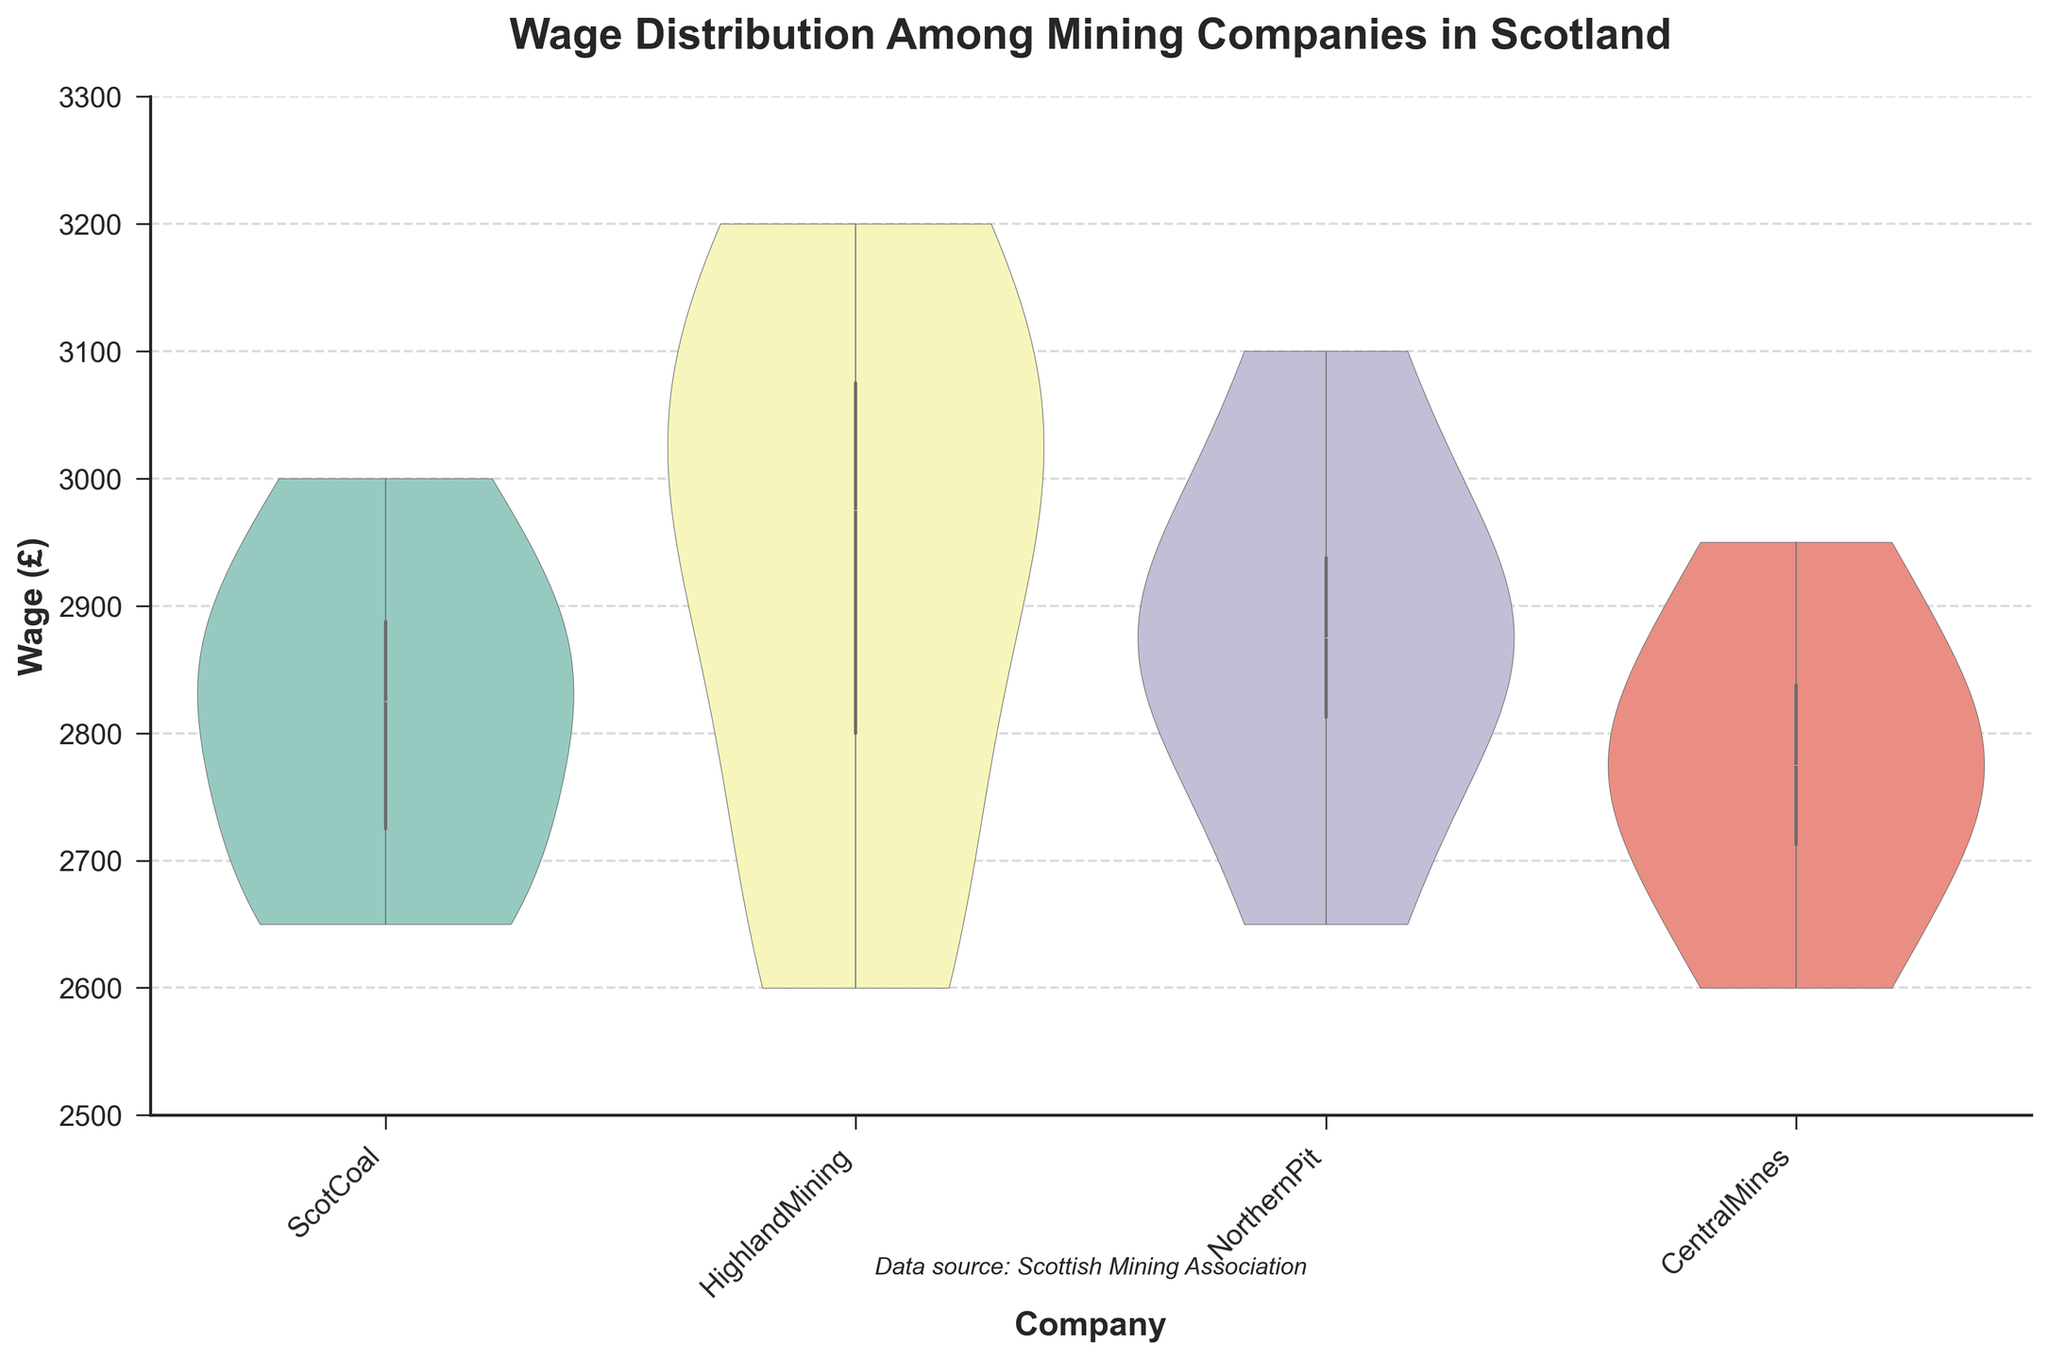What's the title of the figure? The title of the figure is usually the most prominent text and is located at the top of the chart.
Answer: Wage Distribution Among Mining Companies in Scotland What is the range of wages shown on the y-axis? The y-axis is labeled with "Wage (£)" and shows a range from 2500 to 3300 based on the ticks and labels.
Answer: 2500 to 3300 Which company has the highest median wage? The highest median wage can be found by locating the middle line within each violin plot and comparing their vertical positions.
Answer: HighlandMining Among the companies, which one has the most variability in wage distribution? The company with the broadest span in the violin plot indicates the most variability. This can be seen from the width and spread of the violin shape.
Answer: HighlandMining Is the wage for ScotCoal generally higher or lower than CentralMines? Compare the heights and positions of the distribution in the violin plots for ScotCoal and CentralMines. ScotCoal’s median appears slightly higher.
Answer: Higher What is the lower limit of the interquartile range (IQR) for NorthernPit? The interquartile range can be found within the thicker part of the violin plot. For NorthernPit, the lower limit of the IQR appears around 2800.
Answer: 2800 Which company shows the smallest median wage? By finding the middle line inside each violin plot and comparing their heights, the company with the smallest median wage becomes apparent.
Answer: CentralMines Are there any companies with non-overlapping wage distributions? Look for violin plots that do not intersect vertically. These distributions are entirely separate from one another.
Answer: No What visual elements indicate the presence of any outliers in the wage data? Outliers in a violin plot are often indicated by small detached dots or ends that extend significantly beyond the general shape. The presence or absence of these elements informs about the outliers.
Answer: Small detached dots 